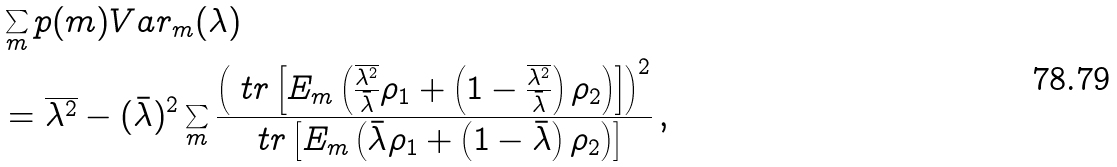<formula> <loc_0><loc_0><loc_500><loc_500>& \sum _ { m } p ( m ) V a r _ { m } ( \lambda ) \\ & = \overline { \lambda ^ { 2 } } - ( \bar { \lambda } ) ^ { 2 } \sum _ { m } \frac { \left ( \ t r \left [ E _ { m } \left ( \frac { \overline { \lambda ^ { 2 } } } { \bar { \lambda } } \rho _ { 1 } + \left ( 1 - \frac { \overline { \lambda ^ { 2 } } } { \bar { \lambda } } \right ) \rho _ { 2 } \right ) \right ] \right ) ^ { 2 } } { \ t r \left [ E _ { m } \left ( \bar { \lambda } \rho _ { 1 } + \left ( 1 - \bar { \lambda } \right ) \rho _ { 2 } \right ) \right ] } \, ,</formula> 